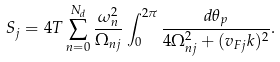Convert formula to latex. <formula><loc_0><loc_0><loc_500><loc_500>S _ { j } = 4 T \sum _ { n = 0 } ^ { N _ { d } } \frac { \omega _ { n } ^ { 2 } } { \Omega _ { n j } } \int _ { 0 } ^ { 2 \pi } \frac { d \theta _ { p } } { 4 \Omega _ { n j } ^ { 2 } + ( { v _ { F j } k } ) ^ { 2 } } .</formula> 